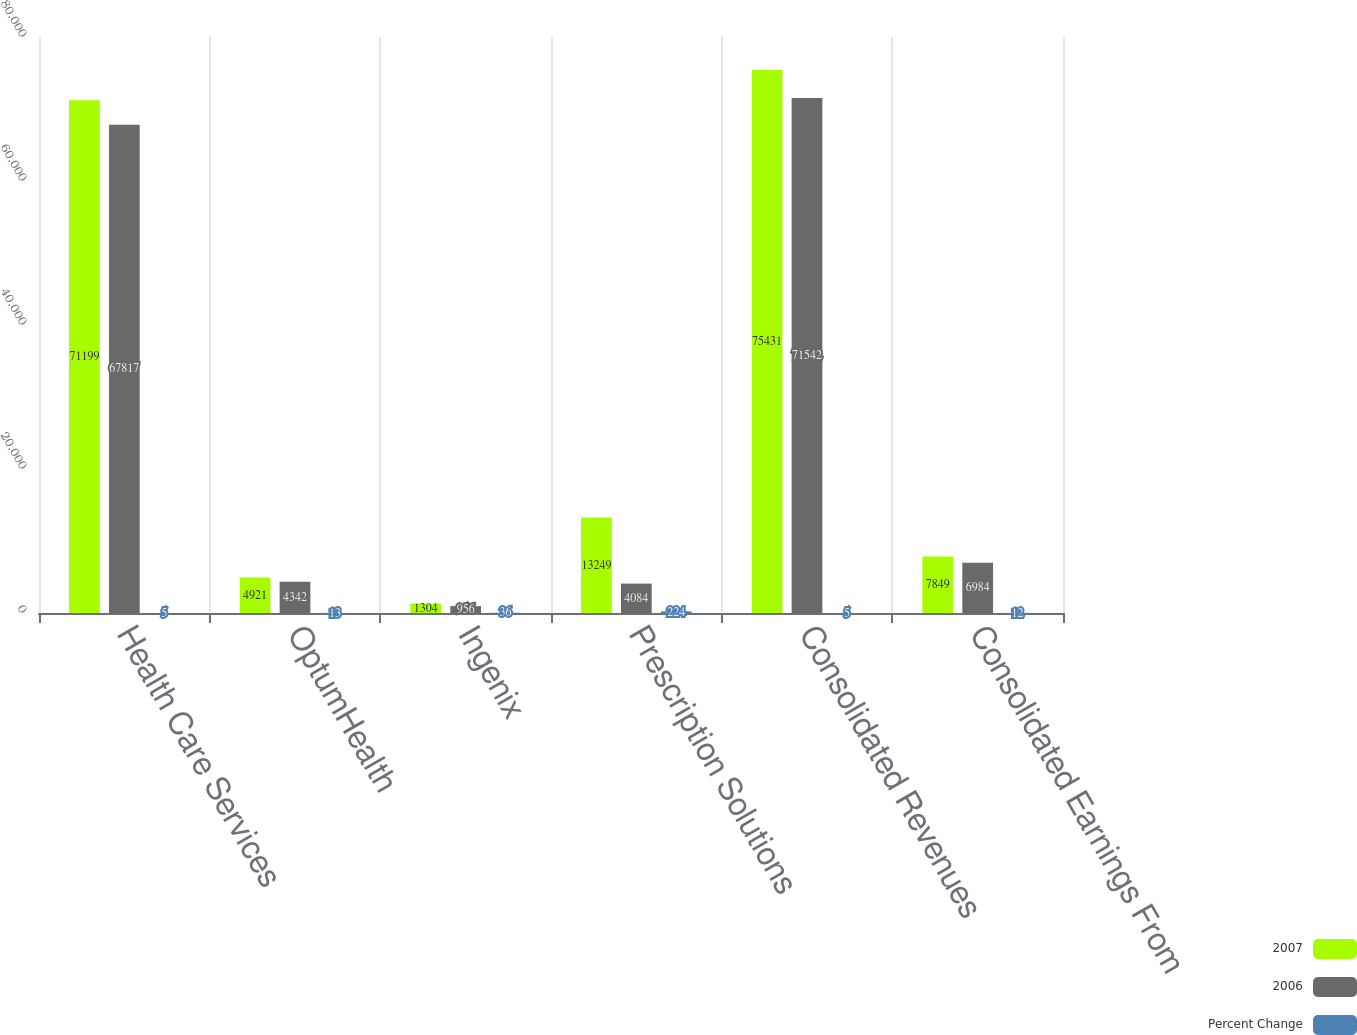<chart> <loc_0><loc_0><loc_500><loc_500><stacked_bar_chart><ecel><fcel>Health Care Services<fcel>OptumHealth<fcel>Ingenix<fcel>Prescription Solutions<fcel>Consolidated Revenues<fcel>Consolidated Earnings From<nl><fcel>2007<fcel>71199<fcel>4921<fcel>1304<fcel>13249<fcel>75431<fcel>7849<nl><fcel>2006<fcel>67817<fcel>4342<fcel>956<fcel>4084<fcel>71542<fcel>6984<nl><fcel>Percent Change<fcel>5<fcel>13<fcel>36<fcel>224<fcel>5<fcel>12<nl></chart> 